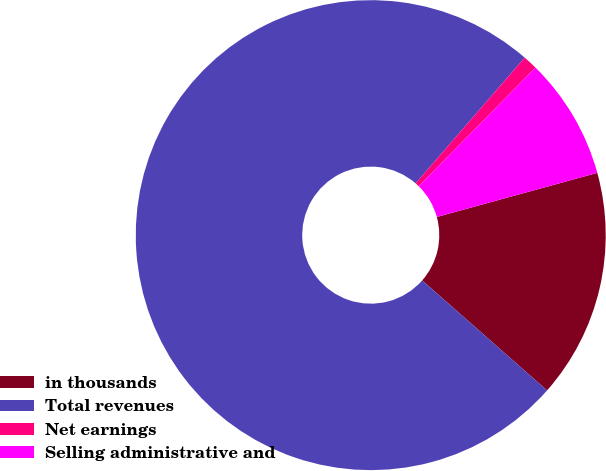Convert chart to OTSL. <chart><loc_0><loc_0><loc_500><loc_500><pie_chart><fcel>in thousands<fcel>Total revenues<fcel>Net earnings<fcel>Selling administrative and<nl><fcel>15.76%<fcel>74.88%<fcel>0.99%<fcel>8.37%<nl></chart> 